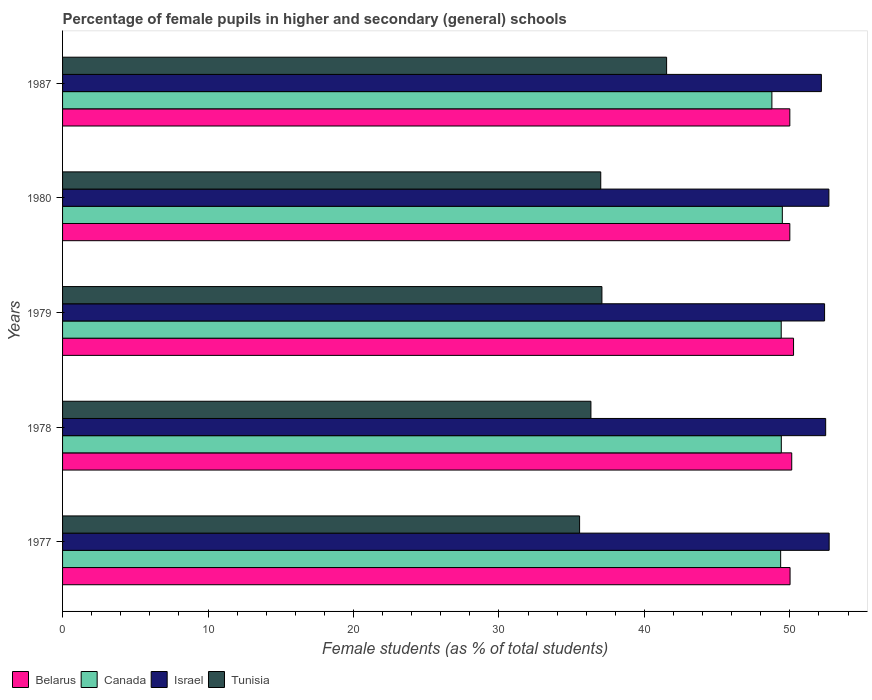What is the label of the 5th group of bars from the top?
Your answer should be compact. 1977. What is the percentage of female pupils in higher and secondary schools in Canada in 1979?
Make the answer very short. 49.41. Across all years, what is the maximum percentage of female pupils in higher and secondary schools in Israel?
Give a very brief answer. 52.7. In which year was the percentage of female pupils in higher and secondary schools in Belarus maximum?
Keep it short and to the point. 1979. What is the total percentage of female pupils in higher and secondary schools in Canada in the graph?
Give a very brief answer. 246.44. What is the difference between the percentage of female pupils in higher and secondary schools in Belarus in 1977 and that in 1987?
Give a very brief answer. 0.02. What is the difference between the percentage of female pupils in higher and secondary schools in Israel in 1979 and the percentage of female pupils in higher and secondary schools in Belarus in 1977?
Keep it short and to the point. 2.37. What is the average percentage of female pupils in higher and secondary schools in Canada per year?
Offer a very short reply. 49.29. In the year 1987, what is the difference between the percentage of female pupils in higher and secondary schools in Belarus and percentage of female pupils in higher and secondary schools in Tunisia?
Your answer should be very brief. 8.47. In how many years, is the percentage of female pupils in higher and secondary schools in Israel greater than 30 %?
Give a very brief answer. 5. What is the ratio of the percentage of female pupils in higher and secondary schools in Tunisia in 1979 to that in 1987?
Offer a terse response. 0.89. What is the difference between the highest and the second highest percentage of female pupils in higher and secondary schools in Belarus?
Give a very brief answer. 0.12. What is the difference between the highest and the lowest percentage of female pupils in higher and secondary schools in Israel?
Keep it short and to the point. 0.54. In how many years, is the percentage of female pupils in higher and secondary schools in Canada greater than the average percentage of female pupils in higher and secondary schools in Canada taken over all years?
Keep it short and to the point. 4. Is the sum of the percentage of female pupils in higher and secondary schools in Belarus in 1980 and 1987 greater than the maximum percentage of female pupils in higher and secondary schools in Tunisia across all years?
Make the answer very short. Yes. What does the 4th bar from the top in 1977 represents?
Make the answer very short. Belarus. What does the 2nd bar from the bottom in 1980 represents?
Make the answer very short. Canada. Is it the case that in every year, the sum of the percentage of female pupils in higher and secondary schools in Canada and percentage of female pupils in higher and secondary schools in Belarus is greater than the percentage of female pupils in higher and secondary schools in Tunisia?
Your answer should be very brief. Yes. Does the graph contain grids?
Your response must be concise. No. How many legend labels are there?
Give a very brief answer. 4. What is the title of the graph?
Make the answer very short. Percentage of female pupils in higher and secondary (general) schools. Does "Libya" appear as one of the legend labels in the graph?
Your answer should be compact. No. What is the label or title of the X-axis?
Offer a very short reply. Female students (as % of total students). What is the label or title of the Y-axis?
Your answer should be very brief. Years. What is the Female students (as % of total students) in Belarus in 1977?
Offer a very short reply. 50.02. What is the Female students (as % of total students) in Canada in 1977?
Ensure brevity in your answer.  49.37. What is the Female students (as % of total students) of Israel in 1977?
Your response must be concise. 52.7. What is the Female students (as % of total students) of Tunisia in 1977?
Give a very brief answer. 35.55. What is the Female students (as % of total students) of Belarus in 1978?
Make the answer very short. 50.13. What is the Female students (as % of total students) of Canada in 1978?
Your response must be concise. 49.41. What is the Female students (as % of total students) in Israel in 1978?
Provide a succinct answer. 52.46. What is the Female students (as % of total students) of Tunisia in 1978?
Keep it short and to the point. 36.33. What is the Female students (as % of total students) of Belarus in 1979?
Offer a terse response. 50.26. What is the Female students (as % of total students) of Canada in 1979?
Ensure brevity in your answer.  49.41. What is the Female students (as % of total students) in Israel in 1979?
Keep it short and to the point. 52.39. What is the Female students (as % of total students) of Tunisia in 1979?
Provide a succinct answer. 37.08. What is the Female students (as % of total students) in Canada in 1980?
Keep it short and to the point. 49.48. What is the Female students (as % of total students) of Israel in 1980?
Provide a succinct answer. 52.69. What is the Female students (as % of total students) in Tunisia in 1980?
Give a very brief answer. 37. What is the Female students (as % of total students) of Belarus in 1987?
Provide a short and direct response. 50. What is the Female students (as % of total students) in Canada in 1987?
Provide a succinct answer. 48.77. What is the Female students (as % of total students) of Israel in 1987?
Ensure brevity in your answer.  52.17. What is the Female students (as % of total students) in Tunisia in 1987?
Give a very brief answer. 41.53. Across all years, what is the maximum Female students (as % of total students) of Belarus?
Make the answer very short. 50.26. Across all years, what is the maximum Female students (as % of total students) of Canada?
Provide a succinct answer. 49.48. Across all years, what is the maximum Female students (as % of total students) of Israel?
Offer a terse response. 52.7. Across all years, what is the maximum Female students (as % of total students) of Tunisia?
Provide a short and direct response. 41.53. Across all years, what is the minimum Female students (as % of total students) of Belarus?
Make the answer very short. 50. Across all years, what is the minimum Female students (as % of total students) in Canada?
Offer a very short reply. 48.77. Across all years, what is the minimum Female students (as % of total students) in Israel?
Make the answer very short. 52.17. Across all years, what is the minimum Female students (as % of total students) of Tunisia?
Provide a succinct answer. 35.55. What is the total Female students (as % of total students) in Belarus in the graph?
Offer a terse response. 250.4. What is the total Female students (as % of total students) of Canada in the graph?
Your answer should be compact. 246.44. What is the total Female students (as % of total students) of Israel in the graph?
Your response must be concise. 262.41. What is the total Female students (as % of total students) of Tunisia in the graph?
Provide a short and direct response. 187.48. What is the difference between the Female students (as % of total students) in Belarus in 1977 and that in 1978?
Offer a terse response. -0.12. What is the difference between the Female students (as % of total students) of Canada in 1977 and that in 1978?
Provide a short and direct response. -0.04. What is the difference between the Female students (as % of total students) of Israel in 1977 and that in 1978?
Provide a short and direct response. 0.24. What is the difference between the Female students (as % of total students) of Tunisia in 1977 and that in 1978?
Offer a very short reply. -0.78. What is the difference between the Female students (as % of total students) in Belarus in 1977 and that in 1979?
Make the answer very short. -0.24. What is the difference between the Female students (as % of total students) of Canada in 1977 and that in 1979?
Offer a terse response. -0.04. What is the difference between the Female students (as % of total students) of Israel in 1977 and that in 1979?
Make the answer very short. 0.31. What is the difference between the Female students (as % of total students) of Tunisia in 1977 and that in 1979?
Give a very brief answer. -1.53. What is the difference between the Female students (as % of total students) of Belarus in 1977 and that in 1980?
Make the answer very short. 0.02. What is the difference between the Female students (as % of total students) of Canada in 1977 and that in 1980?
Your answer should be compact. -0.12. What is the difference between the Female students (as % of total students) of Israel in 1977 and that in 1980?
Your response must be concise. 0.02. What is the difference between the Female students (as % of total students) of Tunisia in 1977 and that in 1980?
Your response must be concise. -1.45. What is the difference between the Female students (as % of total students) of Belarus in 1977 and that in 1987?
Offer a terse response. 0.02. What is the difference between the Female students (as % of total students) of Canada in 1977 and that in 1987?
Give a very brief answer. 0.6. What is the difference between the Female students (as % of total students) in Israel in 1977 and that in 1987?
Your answer should be very brief. 0.54. What is the difference between the Female students (as % of total students) in Tunisia in 1977 and that in 1987?
Ensure brevity in your answer.  -5.98. What is the difference between the Female students (as % of total students) in Belarus in 1978 and that in 1979?
Keep it short and to the point. -0.12. What is the difference between the Female students (as % of total students) of Canada in 1978 and that in 1979?
Ensure brevity in your answer.  0.01. What is the difference between the Female students (as % of total students) in Israel in 1978 and that in 1979?
Offer a terse response. 0.08. What is the difference between the Female students (as % of total students) in Tunisia in 1978 and that in 1979?
Make the answer very short. -0.76. What is the difference between the Female students (as % of total students) of Belarus in 1978 and that in 1980?
Offer a terse response. 0.13. What is the difference between the Female students (as % of total students) in Canada in 1978 and that in 1980?
Offer a very short reply. -0.07. What is the difference between the Female students (as % of total students) of Israel in 1978 and that in 1980?
Offer a very short reply. -0.22. What is the difference between the Female students (as % of total students) of Tunisia in 1978 and that in 1980?
Provide a short and direct response. -0.68. What is the difference between the Female students (as % of total students) in Belarus in 1978 and that in 1987?
Offer a very short reply. 0.13. What is the difference between the Female students (as % of total students) of Canada in 1978 and that in 1987?
Provide a succinct answer. 0.65. What is the difference between the Female students (as % of total students) in Israel in 1978 and that in 1987?
Ensure brevity in your answer.  0.3. What is the difference between the Female students (as % of total students) in Tunisia in 1978 and that in 1987?
Give a very brief answer. -5.2. What is the difference between the Female students (as % of total students) in Belarus in 1979 and that in 1980?
Provide a short and direct response. 0.26. What is the difference between the Female students (as % of total students) in Canada in 1979 and that in 1980?
Keep it short and to the point. -0.08. What is the difference between the Female students (as % of total students) of Israel in 1979 and that in 1980?
Offer a very short reply. -0.3. What is the difference between the Female students (as % of total students) in Tunisia in 1979 and that in 1980?
Your answer should be compact. 0.08. What is the difference between the Female students (as % of total students) of Belarus in 1979 and that in 1987?
Give a very brief answer. 0.26. What is the difference between the Female students (as % of total students) of Canada in 1979 and that in 1987?
Provide a succinct answer. 0.64. What is the difference between the Female students (as % of total students) in Israel in 1979 and that in 1987?
Make the answer very short. 0.22. What is the difference between the Female students (as % of total students) of Tunisia in 1979 and that in 1987?
Give a very brief answer. -4.45. What is the difference between the Female students (as % of total students) in Belarus in 1980 and that in 1987?
Your response must be concise. 0. What is the difference between the Female students (as % of total students) in Canada in 1980 and that in 1987?
Your answer should be compact. 0.72. What is the difference between the Female students (as % of total students) of Israel in 1980 and that in 1987?
Keep it short and to the point. 0.52. What is the difference between the Female students (as % of total students) in Tunisia in 1980 and that in 1987?
Your answer should be very brief. -4.53. What is the difference between the Female students (as % of total students) in Belarus in 1977 and the Female students (as % of total students) in Canada in 1978?
Make the answer very short. 0.6. What is the difference between the Female students (as % of total students) of Belarus in 1977 and the Female students (as % of total students) of Israel in 1978?
Offer a terse response. -2.45. What is the difference between the Female students (as % of total students) of Belarus in 1977 and the Female students (as % of total students) of Tunisia in 1978?
Provide a succinct answer. 13.69. What is the difference between the Female students (as % of total students) of Canada in 1977 and the Female students (as % of total students) of Israel in 1978?
Your answer should be very brief. -3.1. What is the difference between the Female students (as % of total students) in Canada in 1977 and the Female students (as % of total students) in Tunisia in 1978?
Your response must be concise. 13.04. What is the difference between the Female students (as % of total students) of Israel in 1977 and the Female students (as % of total students) of Tunisia in 1978?
Provide a succinct answer. 16.38. What is the difference between the Female students (as % of total students) of Belarus in 1977 and the Female students (as % of total students) of Canada in 1979?
Give a very brief answer. 0.61. What is the difference between the Female students (as % of total students) of Belarus in 1977 and the Female students (as % of total students) of Israel in 1979?
Offer a terse response. -2.37. What is the difference between the Female students (as % of total students) in Belarus in 1977 and the Female students (as % of total students) in Tunisia in 1979?
Your answer should be very brief. 12.94. What is the difference between the Female students (as % of total students) in Canada in 1977 and the Female students (as % of total students) in Israel in 1979?
Your response must be concise. -3.02. What is the difference between the Female students (as % of total students) of Canada in 1977 and the Female students (as % of total students) of Tunisia in 1979?
Make the answer very short. 12.29. What is the difference between the Female students (as % of total students) in Israel in 1977 and the Female students (as % of total students) in Tunisia in 1979?
Keep it short and to the point. 15.62. What is the difference between the Female students (as % of total students) in Belarus in 1977 and the Female students (as % of total students) in Canada in 1980?
Your response must be concise. 0.53. What is the difference between the Female students (as % of total students) in Belarus in 1977 and the Female students (as % of total students) in Israel in 1980?
Your response must be concise. -2.67. What is the difference between the Female students (as % of total students) in Belarus in 1977 and the Female students (as % of total students) in Tunisia in 1980?
Give a very brief answer. 13.02. What is the difference between the Female students (as % of total students) in Canada in 1977 and the Female students (as % of total students) in Israel in 1980?
Provide a short and direct response. -3.32. What is the difference between the Female students (as % of total students) in Canada in 1977 and the Female students (as % of total students) in Tunisia in 1980?
Provide a succinct answer. 12.37. What is the difference between the Female students (as % of total students) of Israel in 1977 and the Female students (as % of total students) of Tunisia in 1980?
Keep it short and to the point. 15.7. What is the difference between the Female students (as % of total students) of Belarus in 1977 and the Female students (as % of total students) of Canada in 1987?
Offer a very short reply. 1.25. What is the difference between the Female students (as % of total students) in Belarus in 1977 and the Female students (as % of total students) in Israel in 1987?
Keep it short and to the point. -2.15. What is the difference between the Female students (as % of total students) of Belarus in 1977 and the Female students (as % of total students) of Tunisia in 1987?
Your answer should be very brief. 8.49. What is the difference between the Female students (as % of total students) in Canada in 1977 and the Female students (as % of total students) in Israel in 1987?
Offer a very short reply. -2.8. What is the difference between the Female students (as % of total students) in Canada in 1977 and the Female students (as % of total students) in Tunisia in 1987?
Your answer should be compact. 7.84. What is the difference between the Female students (as % of total students) in Israel in 1977 and the Female students (as % of total students) in Tunisia in 1987?
Offer a terse response. 11.18. What is the difference between the Female students (as % of total students) of Belarus in 1978 and the Female students (as % of total students) of Canada in 1979?
Your response must be concise. 0.72. What is the difference between the Female students (as % of total students) of Belarus in 1978 and the Female students (as % of total students) of Israel in 1979?
Ensure brevity in your answer.  -2.26. What is the difference between the Female students (as % of total students) in Belarus in 1978 and the Female students (as % of total students) in Tunisia in 1979?
Keep it short and to the point. 13.05. What is the difference between the Female students (as % of total students) of Canada in 1978 and the Female students (as % of total students) of Israel in 1979?
Your answer should be very brief. -2.98. What is the difference between the Female students (as % of total students) in Canada in 1978 and the Female students (as % of total students) in Tunisia in 1979?
Provide a short and direct response. 12.33. What is the difference between the Female students (as % of total students) in Israel in 1978 and the Female students (as % of total students) in Tunisia in 1979?
Ensure brevity in your answer.  15.38. What is the difference between the Female students (as % of total students) in Belarus in 1978 and the Female students (as % of total students) in Canada in 1980?
Your response must be concise. 0.65. What is the difference between the Female students (as % of total students) in Belarus in 1978 and the Female students (as % of total students) in Israel in 1980?
Your answer should be very brief. -2.55. What is the difference between the Female students (as % of total students) in Belarus in 1978 and the Female students (as % of total students) in Tunisia in 1980?
Provide a short and direct response. 13.13. What is the difference between the Female students (as % of total students) of Canada in 1978 and the Female students (as % of total students) of Israel in 1980?
Make the answer very short. -3.27. What is the difference between the Female students (as % of total students) in Canada in 1978 and the Female students (as % of total students) in Tunisia in 1980?
Make the answer very short. 12.41. What is the difference between the Female students (as % of total students) in Israel in 1978 and the Female students (as % of total students) in Tunisia in 1980?
Make the answer very short. 15.46. What is the difference between the Female students (as % of total students) of Belarus in 1978 and the Female students (as % of total students) of Canada in 1987?
Offer a very short reply. 1.36. What is the difference between the Female students (as % of total students) in Belarus in 1978 and the Female students (as % of total students) in Israel in 1987?
Keep it short and to the point. -2.04. What is the difference between the Female students (as % of total students) in Belarus in 1978 and the Female students (as % of total students) in Tunisia in 1987?
Offer a terse response. 8.6. What is the difference between the Female students (as % of total students) of Canada in 1978 and the Female students (as % of total students) of Israel in 1987?
Offer a terse response. -2.75. What is the difference between the Female students (as % of total students) of Canada in 1978 and the Female students (as % of total students) of Tunisia in 1987?
Provide a succinct answer. 7.89. What is the difference between the Female students (as % of total students) in Israel in 1978 and the Female students (as % of total students) in Tunisia in 1987?
Your answer should be very brief. 10.94. What is the difference between the Female students (as % of total students) in Belarus in 1979 and the Female students (as % of total students) in Canada in 1980?
Your answer should be compact. 0.77. What is the difference between the Female students (as % of total students) in Belarus in 1979 and the Female students (as % of total students) in Israel in 1980?
Provide a short and direct response. -2.43. What is the difference between the Female students (as % of total students) in Belarus in 1979 and the Female students (as % of total students) in Tunisia in 1980?
Offer a terse response. 13.26. What is the difference between the Female students (as % of total students) in Canada in 1979 and the Female students (as % of total students) in Israel in 1980?
Offer a terse response. -3.28. What is the difference between the Female students (as % of total students) of Canada in 1979 and the Female students (as % of total students) of Tunisia in 1980?
Give a very brief answer. 12.41. What is the difference between the Female students (as % of total students) in Israel in 1979 and the Female students (as % of total students) in Tunisia in 1980?
Keep it short and to the point. 15.39. What is the difference between the Female students (as % of total students) of Belarus in 1979 and the Female students (as % of total students) of Canada in 1987?
Your answer should be very brief. 1.49. What is the difference between the Female students (as % of total students) of Belarus in 1979 and the Female students (as % of total students) of Israel in 1987?
Your answer should be compact. -1.91. What is the difference between the Female students (as % of total students) in Belarus in 1979 and the Female students (as % of total students) in Tunisia in 1987?
Your answer should be very brief. 8.73. What is the difference between the Female students (as % of total students) in Canada in 1979 and the Female students (as % of total students) in Israel in 1987?
Your response must be concise. -2.76. What is the difference between the Female students (as % of total students) in Canada in 1979 and the Female students (as % of total students) in Tunisia in 1987?
Provide a succinct answer. 7.88. What is the difference between the Female students (as % of total students) of Israel in 1979 and the Female students (as % of total students) of Tunisia in 1987?
Keep it short and to the point. 10.86. What is the difference between the Female students (as % of total students) of Belarus in 1980 and the Female students (as % of total students) of Canada in 1987?
Provide a short and direct response. 1.23. What is the difference between the Female students (as % of total students) of Belarus in 1980 and the Female students (as % of total students) of Israel in 1987?
Provide a short and direct response. -2.17. What is the difference between the Female students (as % of total students) of Belarus in 1980 and the Female students (as % of total students) of Tunisia in 1987?
Your answer should be compact. 8.47. What is the difference between the Female students (as % of total students) of Canada in 1980 and the Female students (as % of total students) of Israel in 1987?
Offer a very short reply. -2.68. What is the difference between the Female students (as % of total students) in Canada in 1980 and the Female students (as % of total students) in Tunisia in 1987?
Give a very brief answer. 7.96. What is the difference between the Female students (as % of total students) in Israel in 1980 and the Female students (as % of total students) in Tunisia in 1987?
Ensure brevity in your answer.  11.16. What is the average Female students (as % of total students) of Belarus per year?
Your answer should be compact. 50.08. What is the average Female students (as % of total students) in Canada per year?
Keep it short and to the point. 49.29. What is the average Female students (as % of total students) in Israel per year?
Give a very brief answer. 52.48. What is the average Female students (as % of total students) in Tunisia per year?
Your answer should be very brief. 37.5. In the year 1977, what is the difference between the Female students (as % of total students) in Belarus and Female students (as % of total students) in Canada?
Make the answer very short. 0.65. In the year 1977, what is the difference between the Female students (as % of total students) in Belarus and Female students (as % of total students) in Israel?
Keep it short and to the point. -2.69. In the year 1977, what is the difference between the Female students (as % of total students) in Belarus and Female students (as % of total students) in Tunisia?
Offer a terse response. 14.47. In the year 1977, what is the difference between the Female students (as % of total students) of Canada and Female students (as % of total students) of Israel?
Provide a short and direct response. -3.33. In the year 1977, what is the difference between the Female students (as % of total students) in Canada and Female students (as % of total students) in Tunisia?
Your answer should be compact. 13.82. In the year 1977, what is the difference between the Female students (as % of total students) of Israel and Female students (as % of total students) of Tunisia?
Ensure brevity in your answer.  17.16. In the year 1978, what is the difference between the Female students (as % of total students) in Belarus and Female students (as % of total students) in Canada?
Your response must be concise. 0.72. In the year 1978, what is the difference between the Female students (as % of total students) in Belarus and Female students (as % of total students) in Israel?
Give a very brief answer. -2.33. In the year 1978, what is the difference between the Female students (as % of total students) of Belarus and Female students (as % of total students) of Tunisia?
Provide a succinct answer. 13.81. In the year 1978, what is the difference between the Female students (as % of total students) of Canada and Female students (as % of total students) of Israel?
Ensure brevity in your answer.  -3.05. In the year 1978, what is the difference between the Female students (as % of total students) in Canada and Female students (as % of total students) in Tunisia?
Your answer should be compact. 13.09. In the year 1978, what is the difference between the Female students (as % of total students) of Israel and Female students (as % of total students) of Tunisia?
Ensure brevity in your answer.  16.14. In the year 1979, what is the difference between the Female students (as % of total students) of Belarus and Female students (as % of total students) of Canada?
Provide a succinct answer. 0.85. In the year 1979, what is the difference between the Female students (as % of total students) in Belarus and Female students (as % of total students) in Israel?
Your response must be concise. -2.13. In the year 1979, what is the difference between the Female students (as % of total students) of Belarus and Female students (as % of total students) of Tunisia?
Offer a very short reply. 13.17. In the year 1979, what is the difference between the Female students (as % of total students) in Canada and Female students (as % of total students) in Israel?
Provide a short and direct response. -2.98. In the year 1979, what is the difference between the Female students (as % of total students) in Canada and Female students (as % of total students) in Tunisia?
Offer a very short reply. 12.33. In the year 1979, what is the difference between the Female students (as % of total students) of Israel and Female students (as % of total students) of Tunisia?
Offer a very short reply. 15.31. In the year 1980, what is the difference between the Female students (as % of total students) in Belarus and Female students (as % of total students) in Canada?
Provide a short and direct response. 0.52. In the year 1980, what is the difference between the Female students (as % of total students) of Belarus and Female students (as % of total students) of Israel?
Provide a short and direct response. -2.69. In the year 1980, what is the difference between the Female students (as % of total students) in Belarus and Female students (as % of total students) in Tunisia?
Offer a very short reply. 13. In the year 1980, what is the difference between the Female students (as % of total students) of Canada and Female students (as % of total students) of Israel?
Provide a succinct answer. -3.2. In the year 1980, what is the difference between the Female students (as % of total students) in Canada and Female students (as % of total students) in Tunisia?
Provide a short and direct response. 12.48. In the year 1980, what is the difference between the Female students (as % of total students) in Israel and Female students (as % of total students) in Tunisia?
Make the answer very short. 15.68. In the year 1987, what is the difference between the Female students (as % of total students) of Belarus and Female students (as % of total students) of Canada?
Make the answer very short. 1.23. In the year 1987, what is the difference between the Female students (as % of total students) of Belarus and Female students (as % of total students) of Israel?
Offer a very short reply. -2.17. In the year 1987, what is the difference between the Female students (as % of total students) in Belarus and Female students (as % of total students) in Tunisia?
Provide a succinct answer. 8.47. In the year 1987, what is the difference between the Female students (as % of total students) of Canada and Female students (as % of total students) of Israel?
Your answer should be very brief. -3.4. In the year 1987, what is the difference between the Female students (as % of total students) of Canada and Female students (as % of total students) of Tunisia?
Your answer should be very brief. 7.24. In the year 1987, what is the difference between the Female students (as % of total students) of Israel and Female students (as % of total students) of Tunisia?
Offer a terse response. 10.64. What is the ratio of the Female students (as % of total students) in Belarus in 1977 to that in 1978?
Your answer should be very brief. 1. What is the ratio of the Female students (as % of total students) in Canada in 1977 to that in 1978?
Ensure brevity in your answer.  1. What is the ratio of the Female students (as % of total students) in Israel in 1977 to that in 1978?
Your response must be concise. 1. What is the ratio of the Female students (as % of total students) of Tunisia in 1977 to that in 1978?
Your answer should be compact. 0.98. What is the ratio of the Female students (as % of total students) in Canada in 1977 to that in 1979?
Your answer should be very brief. 1. What is the ratio of the Female students (as % of total students) of Israel in 1977 to that in 1979?
Provide a succinct answer. 1.01. What is the ratio of the Female students (as % of total students) of Tunisia in 1977 to that in 1979?
Ensure brevity in your answer.  0.96. What is the ratio of the Female students (as % of total students) of Belarus in 1977 to that in 1980?
Ensure brevity in your answer.  1. What is the ratio of the Female students (as % of total students) in Israel in 1977 to that in 1980?
Offer a terse response. 1. What is the ratio of the Female students (as % of total students) in Tunisia in 1977 to that in 1980?
Provide a succinct answer. 0.96. What is the ratio of the Female students (as % of total students) in Belarus in 1977 to that in 1987?
Your response must be concise. 1. What is the ratio of the Female students (as % of total students) of Canada in 1977 to that in 1987?
Make the answer very short. 1.01. What is the ratio of the Female students (as % of total students) of Israel in 1977 to that in 1987?
Provide a succinct answer. 1.01. What is the ratio of the Female students (as % of total students) of Tunisia in 1977 to that in 1987?
Your response must be concise. 0.86. What is the ratio of the Female students (as % of total students) of Belarus in 1978 to that in 1979?
Give a very brief answer. 1. What is the ratio of the Female students (as % of total students) of Canada in 1978 to that in 1979?
Ensure brevity in your answer.  1. What is the ratio of the Female students (as % of total students) in Tunisia in 1978 to that in 1979?
Offer a terse response. 0.98. What is the ratio of the Female students (as % of total students) in Canada in 1978 to that in 1980?
Ensure brevity in your answer.  1. What is the ratio of the Female students (as % of total students) of Israel in 1978 to that in 1980?
Your response must be concise. 1. What is the ratio of the Female students (as % of total students) in Tunisia in 1978 to that in 1980?
Offer a terse response. 0.98. What is the ratio of the Female students (as % of total students) of Belarus in 1978 to that in 1987?
Give a very brief answer. 1. What is the ratio of the Female students (as % of total students) of Canada in 1978 to that in 1987?
Your response must be concise. 1.01. What is the ratio of the Female students (as % of total students) of Israel in 1978 to that in 1987?
Provide a succinct answer. 1.01. What is the ratio of the Female students (as % of total students) of Tunisia in 1978 to that in 1987?
Provide a short and direct response. 0.87. What is the ratio of the Female students (as % of total students) in Israel in 1979 to that in 1980?
Provide a short and direct response. 0.99. What is the ratio of the Female students (as % of total students) in Canada in 1979 to that in 1987?
Give a very brief answer. 1.01. What is the ratio of the Female students (as % of total students) in Tunisia in 1979 to that in 1987?
Your response must be concise. 0.89. What is the ratio of the Female students (as % of total students) in Belarus in 1980 to that in 1987?
Keep it short and to the point. 1. What is the ratio of the Female students (as % of total students) in Canada in 1980 to that in 1987?
Your response must be concise. 1.01. What is the ratio of the Female students (as % of total students) of Israel in 1980 to that in 1987?
Offer a very short reply. 1.01. What is the ratio of the Female students (as % of total students) in Tunisia in 1980 to that in 1987?
Ensure brevity in your answer.  0.89. What is the difference between the highest and the second highest Female students (as % of total students) of Belarus?
Provide a short and direct response. 0.12. What is the difference between the highest and the second highest Female students (as % of total students) in Canada?
Ensure brevity in your answer.  0.07. What is the difference between the highest and the second highest Female students (as % of total students) in Israel?
Your answer should be compact. 0.02. What is the difference between the highest and the second highest Female students (as % of total students) in Tunisia?
Provide a succinct answer. 4.45. What is the difference between the highest and the lowest Female students (as % of total students) of Belarus?
Offer a terse response. 0.26. What is the difference between the highest and the lowest Female students (as % of total students) in Canada?
Offer a very short reply. 0.72. What is the difference between the highest and the lowest Female students (as % of total students) in Israel?
Ensure brevity in your answer.  0.54. What is the difference between the highest and the lowest Female students (as % of total students) of Tunisia?
Make the answer very short. 5.98. 